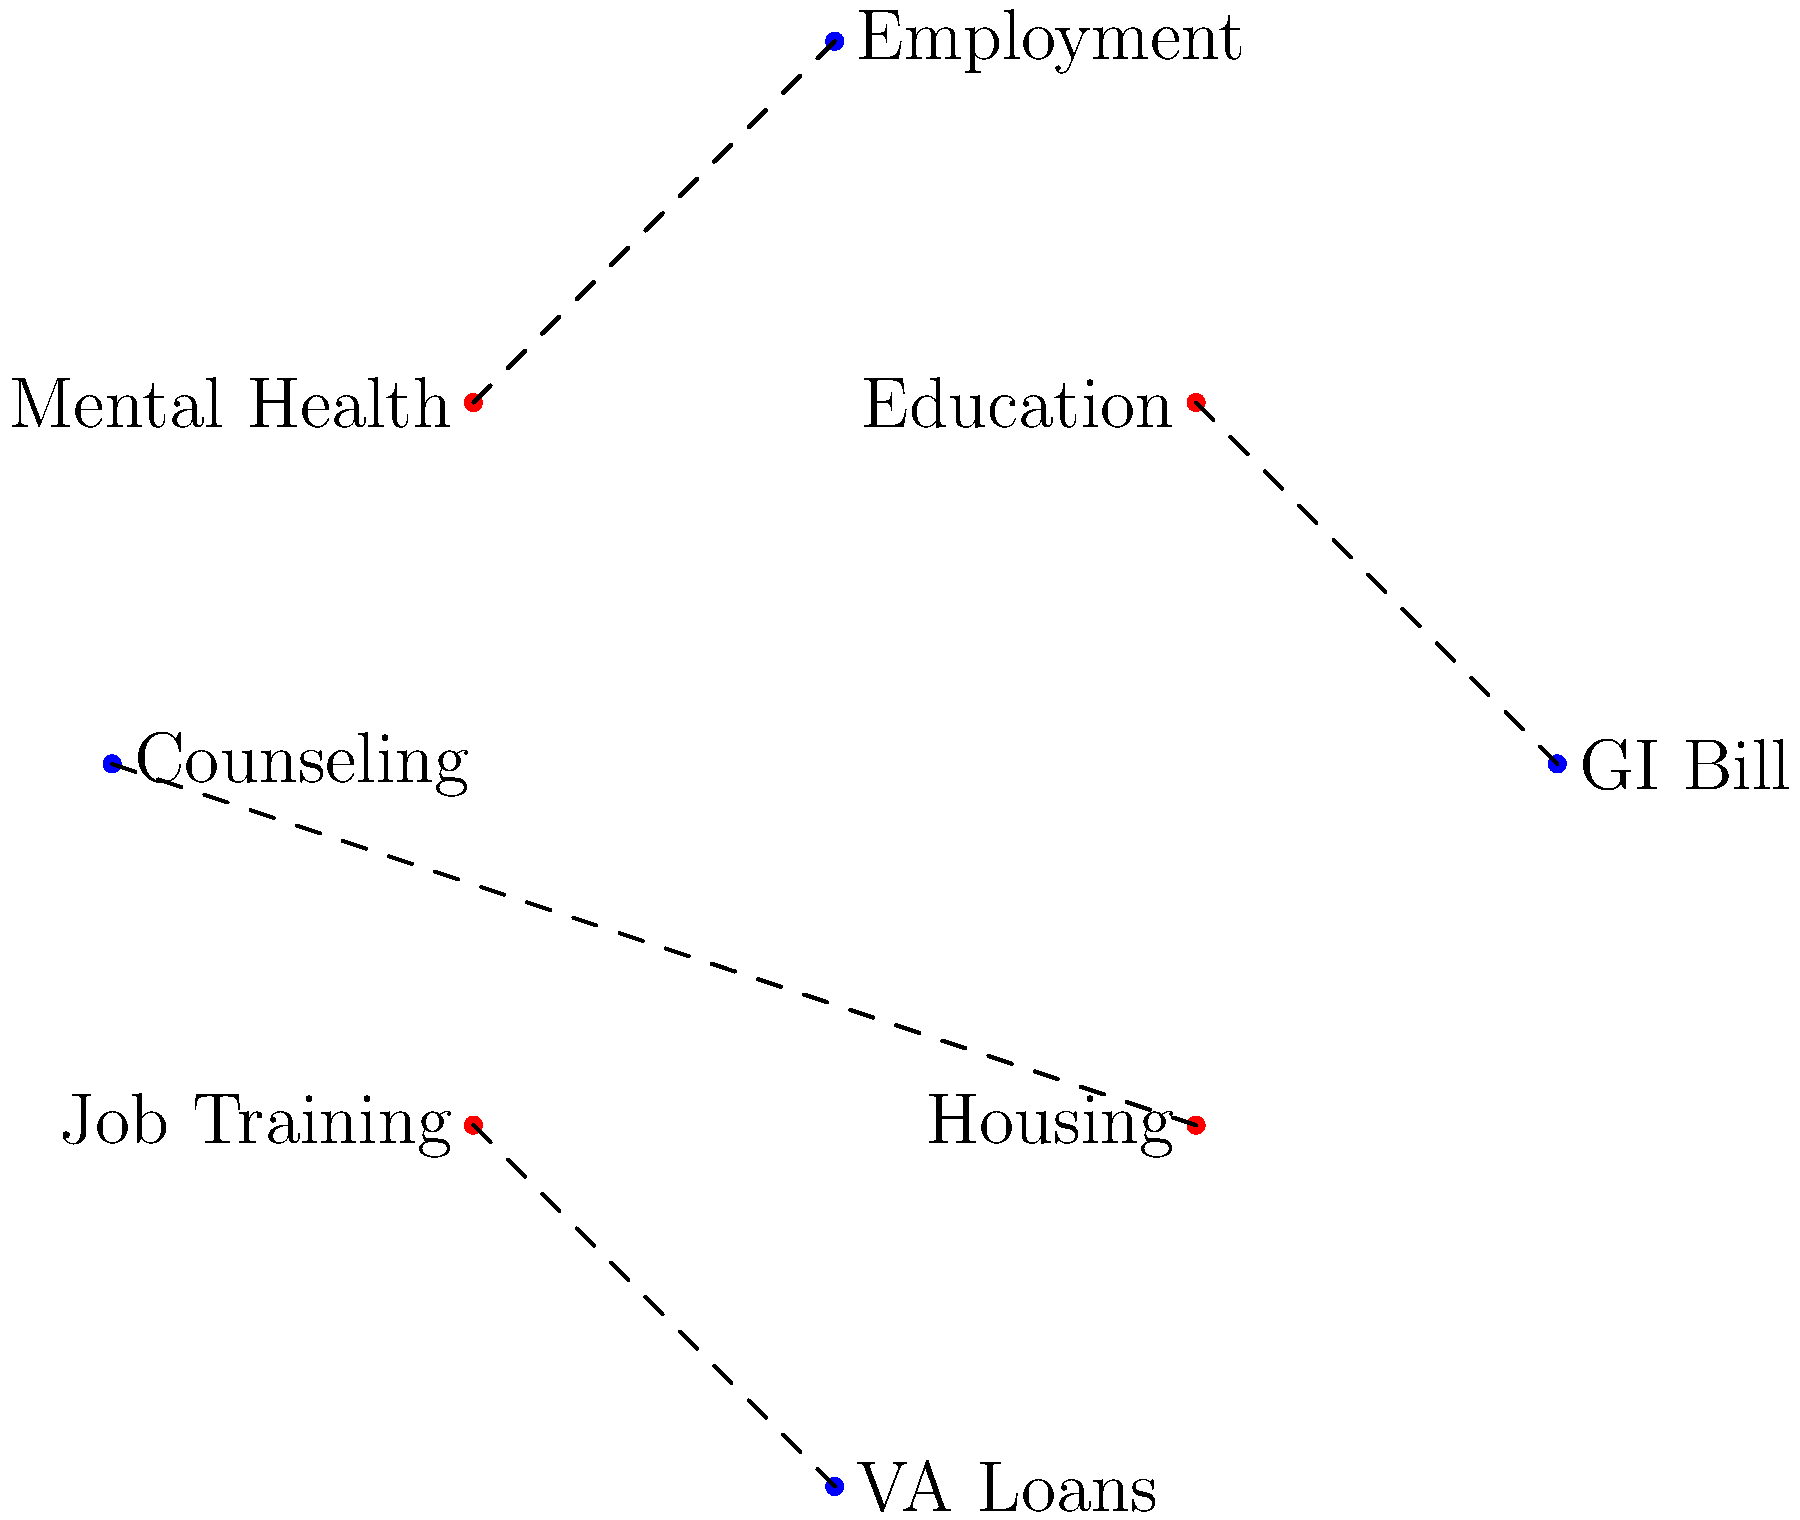Connect each veteran support service to its corresponding benefit by drawing lines between them. Which service is correctly linked to the VA Loans benefit? To solve this puzzle, we need to match each support service with its most relevant benefit:

1. Mental Health should be connected to Counseling
2. Job Training should be connected to Employment
3. Education should be connected to GI Bill
4. Housing should be connected to VA Loans

Following these connections:

1. Mental Health (top-left) connects to Counseling (top)
2. Job Training (bottom-left) connects to Employment (bottom)
3. Education (top-right) connects to GI Bill (right)
4. Housing (bottom-right) connects to VA Loans (left)

Therefore, the service correctly linked to VA Loans is Housing.
Answer: Housing 